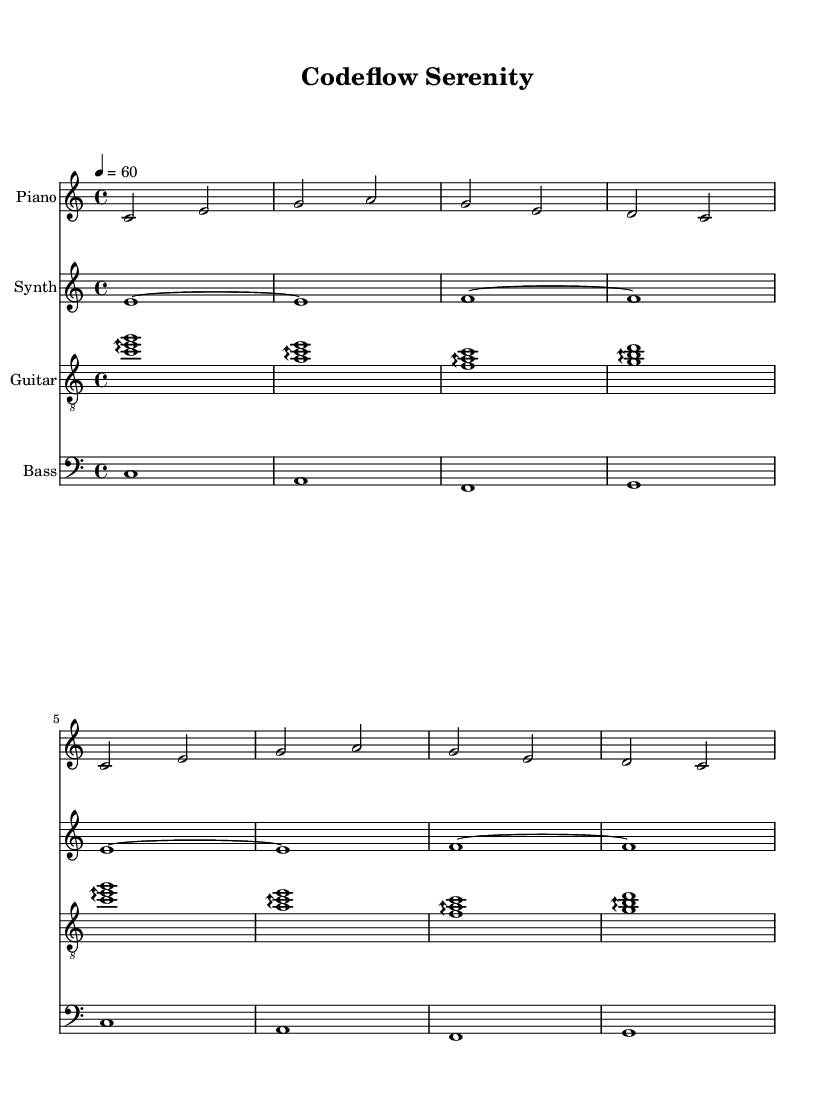What is the key signature of this music? The key signature is C major, which is indicated by the absence of any sharps or flats on the staff. In a C major key, notes such as C, D, E, F, G, A, and B are utilized without alterations.
Answer: C major What is the time signature of the piece? The time signature shown in the music is 4/4, which indicates that there are four beats in each measure and the quarter note receives one beat. This is a common time signature for many types of music, promoting a steady and straightforward rhythm.
Answer: 4/4 What is the tempo marking of this composition? The tempo marking is indicated as 4 equals 60, meaning that there are 60 beats per minute. This slower tempo is conducive to a calm and focused atmosphere, making it suitable for studying or coding.
Answer: 60 How many measures does the music contain? The music consists of 8 measures. This can be determined by counting the bars in the piano, synth, guitar, and bass staves, ensuring that all parts are included in the total.
Answer: 8 What instrument plays the arpeggios prominently? The guitar plays the arpeggios prominently in this piece, as seen in its part where chords are broken into individual notes played sequentially rather than simultaneously, creating a flowing texture.
Answer: Guitar What is the duration of the first note in the synth part? The first note in the synth part is a whole note, which lasts for four beats, as indicated by the whole note symbol that stretches across the entire measure.
Answer: Whole note Which staff has the lowest pitch range? The bass staff has the lowest pitch range, as it is notated in the bass clef, which is designed for lower pitches compared to the treble clef used for piano, synth, and guitar.
Answer: Bass 